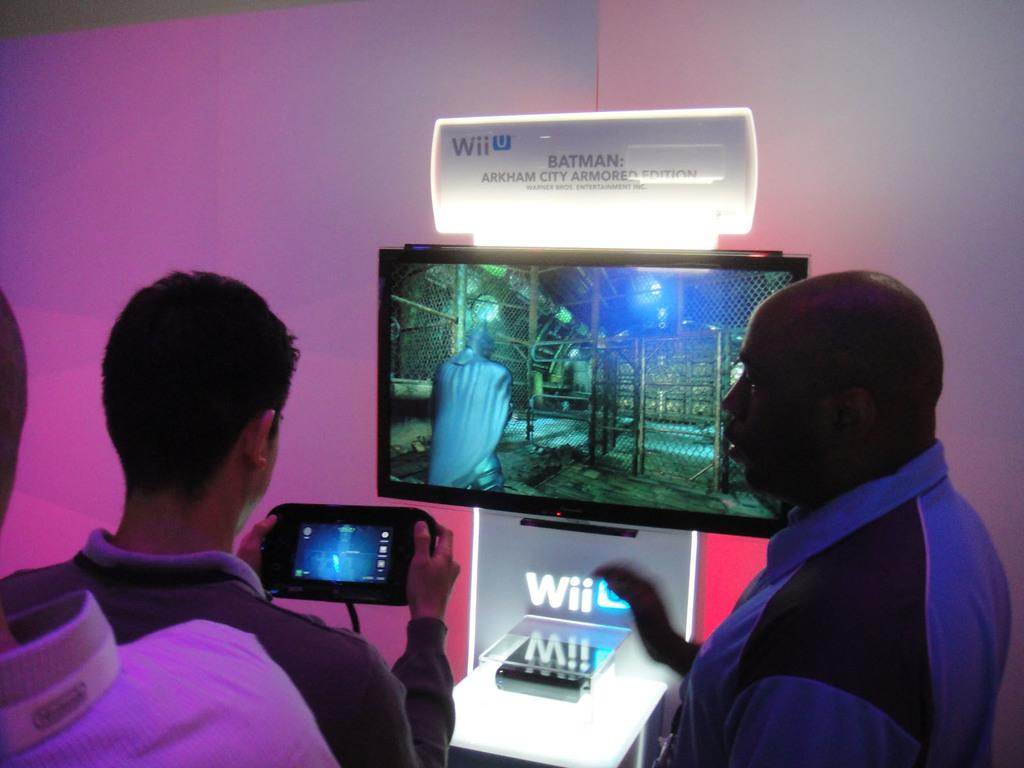<image>
Write a terse but informative summary of the picture. the words Wii below the television above it 